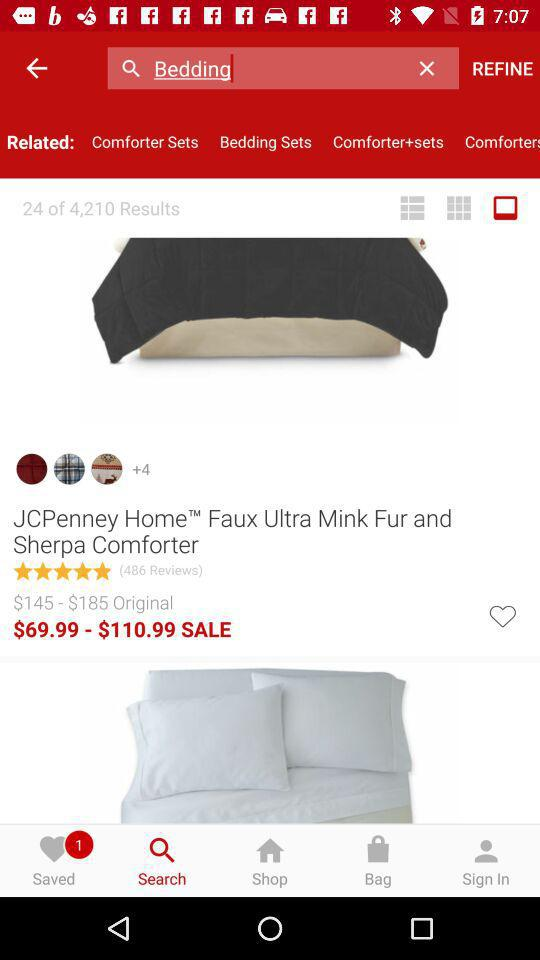Which result number are we on? You are on result number 24. 